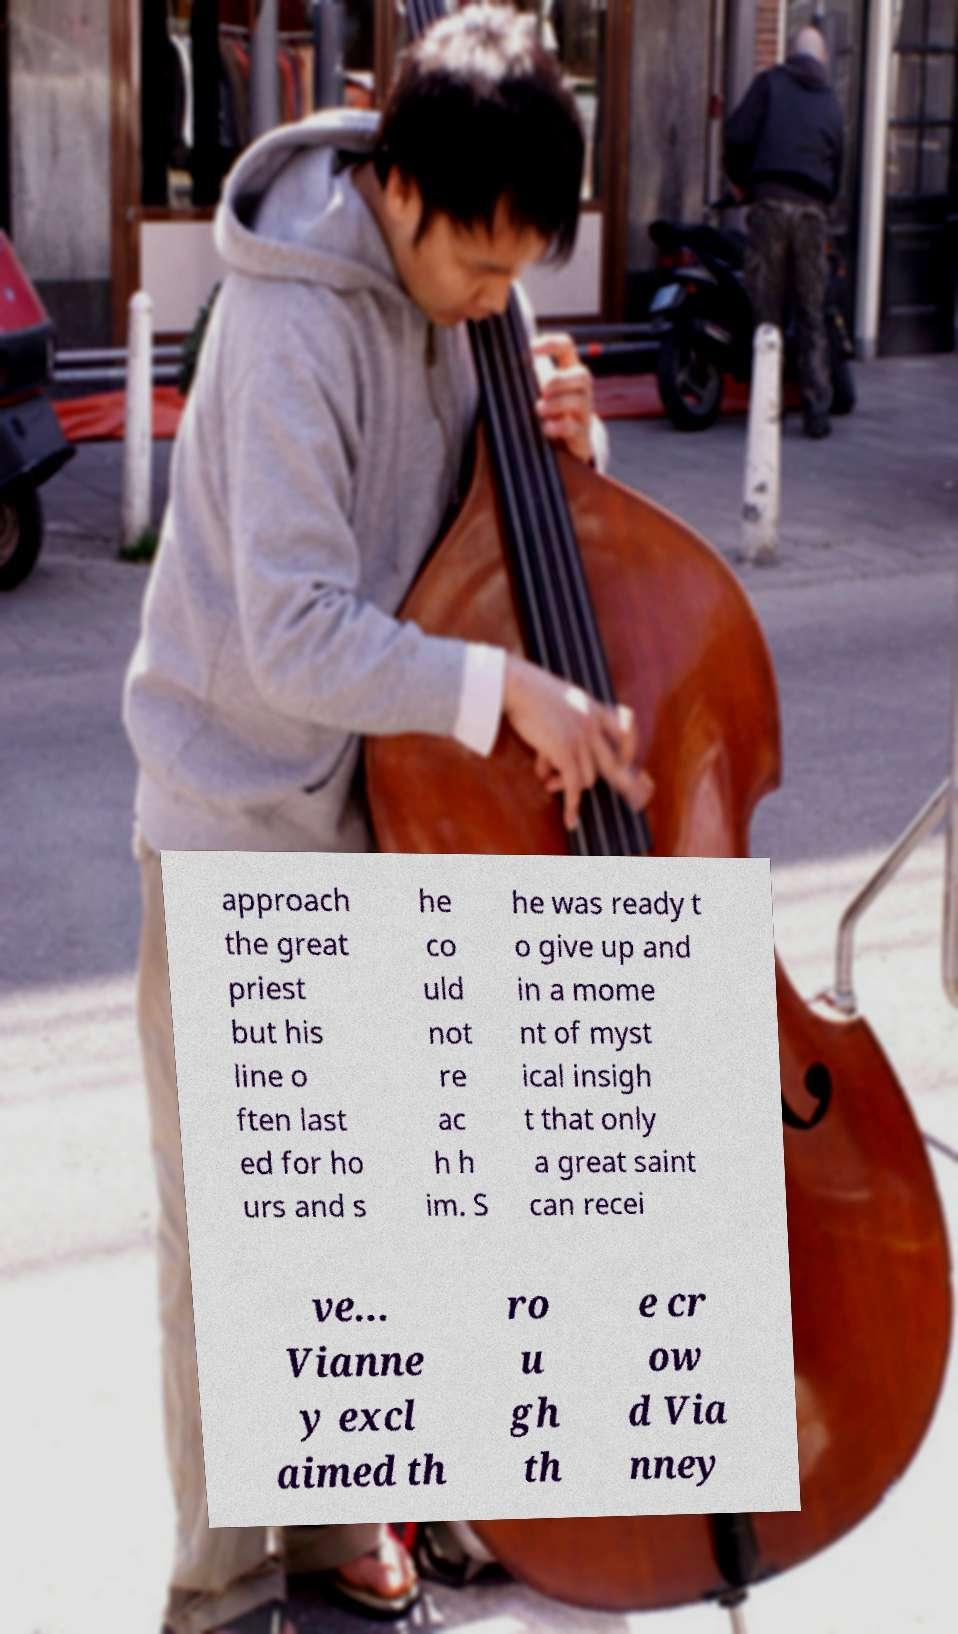Could you extract and type out the text from this image? approach the great priest but his line o ften last ed for ho urs and s he co uld not re ac h h im. S he was ready t o give up and in a mome nt of myst ical insigh t that only a great saint can recei ve... Vianne y excl aimed th ro u gh th e cr ow d Via nney 